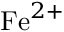Convert formula to latex. <formula><loc_0><loc_0><loc_500><loc_500>F e ^ { 2 + }</formula> 